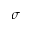<formula> <loc_0><loc_0><loc_500><loc_500>\sigma</formula> 